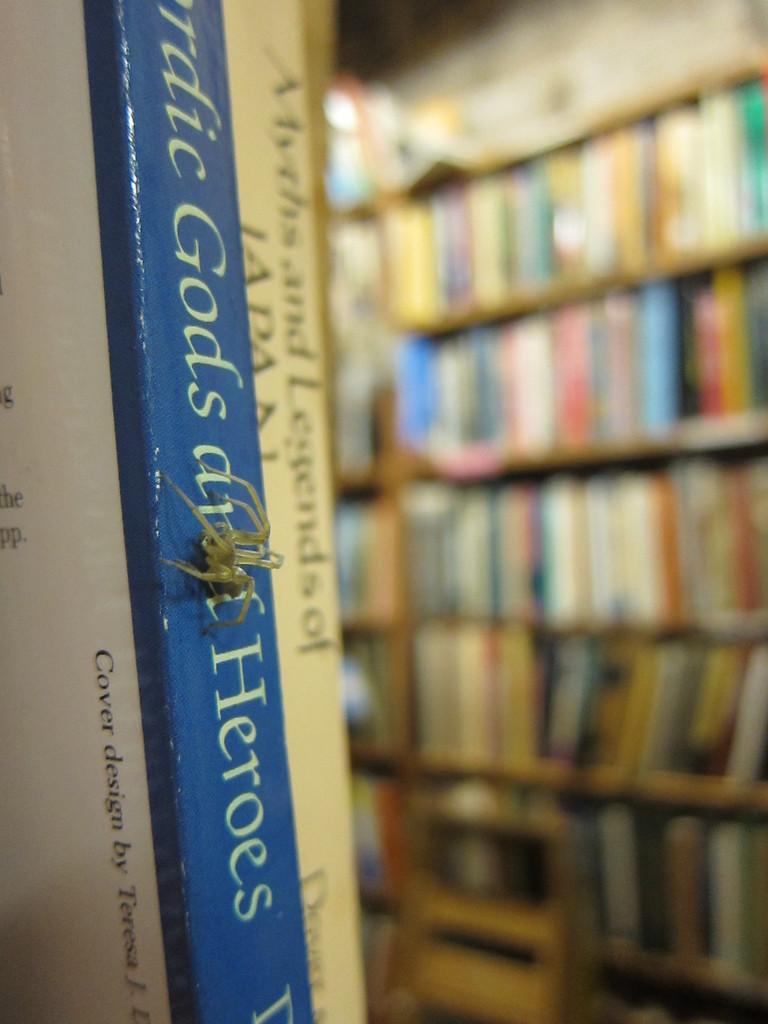Is the blue book about gods and heroes?
Provide a short and direct response. Yes. 